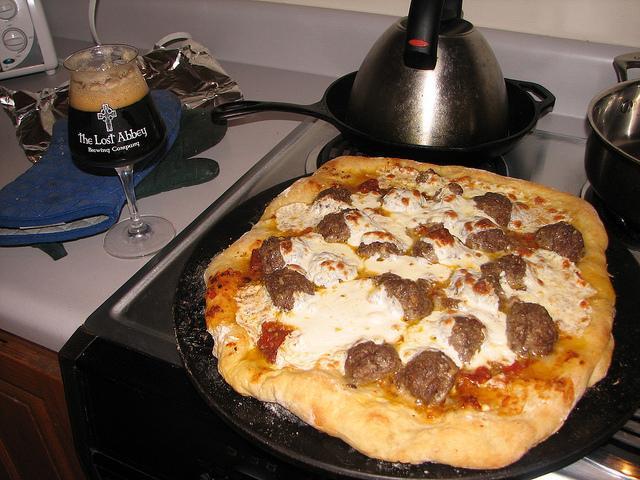Is the given caption "The oven contains the pizza." fitting for the image?
Answer yes or no. No. Is this affirmation: "The pizza is in the oven." correct?
Answer yes or no. No. Evaluate: Does the caption "The pizza is into the oven." match the image?
Answer yes or no. No. Is the caption "The pizza is above the oven." a true representation of the image?
Answer yes or no. Yes. 